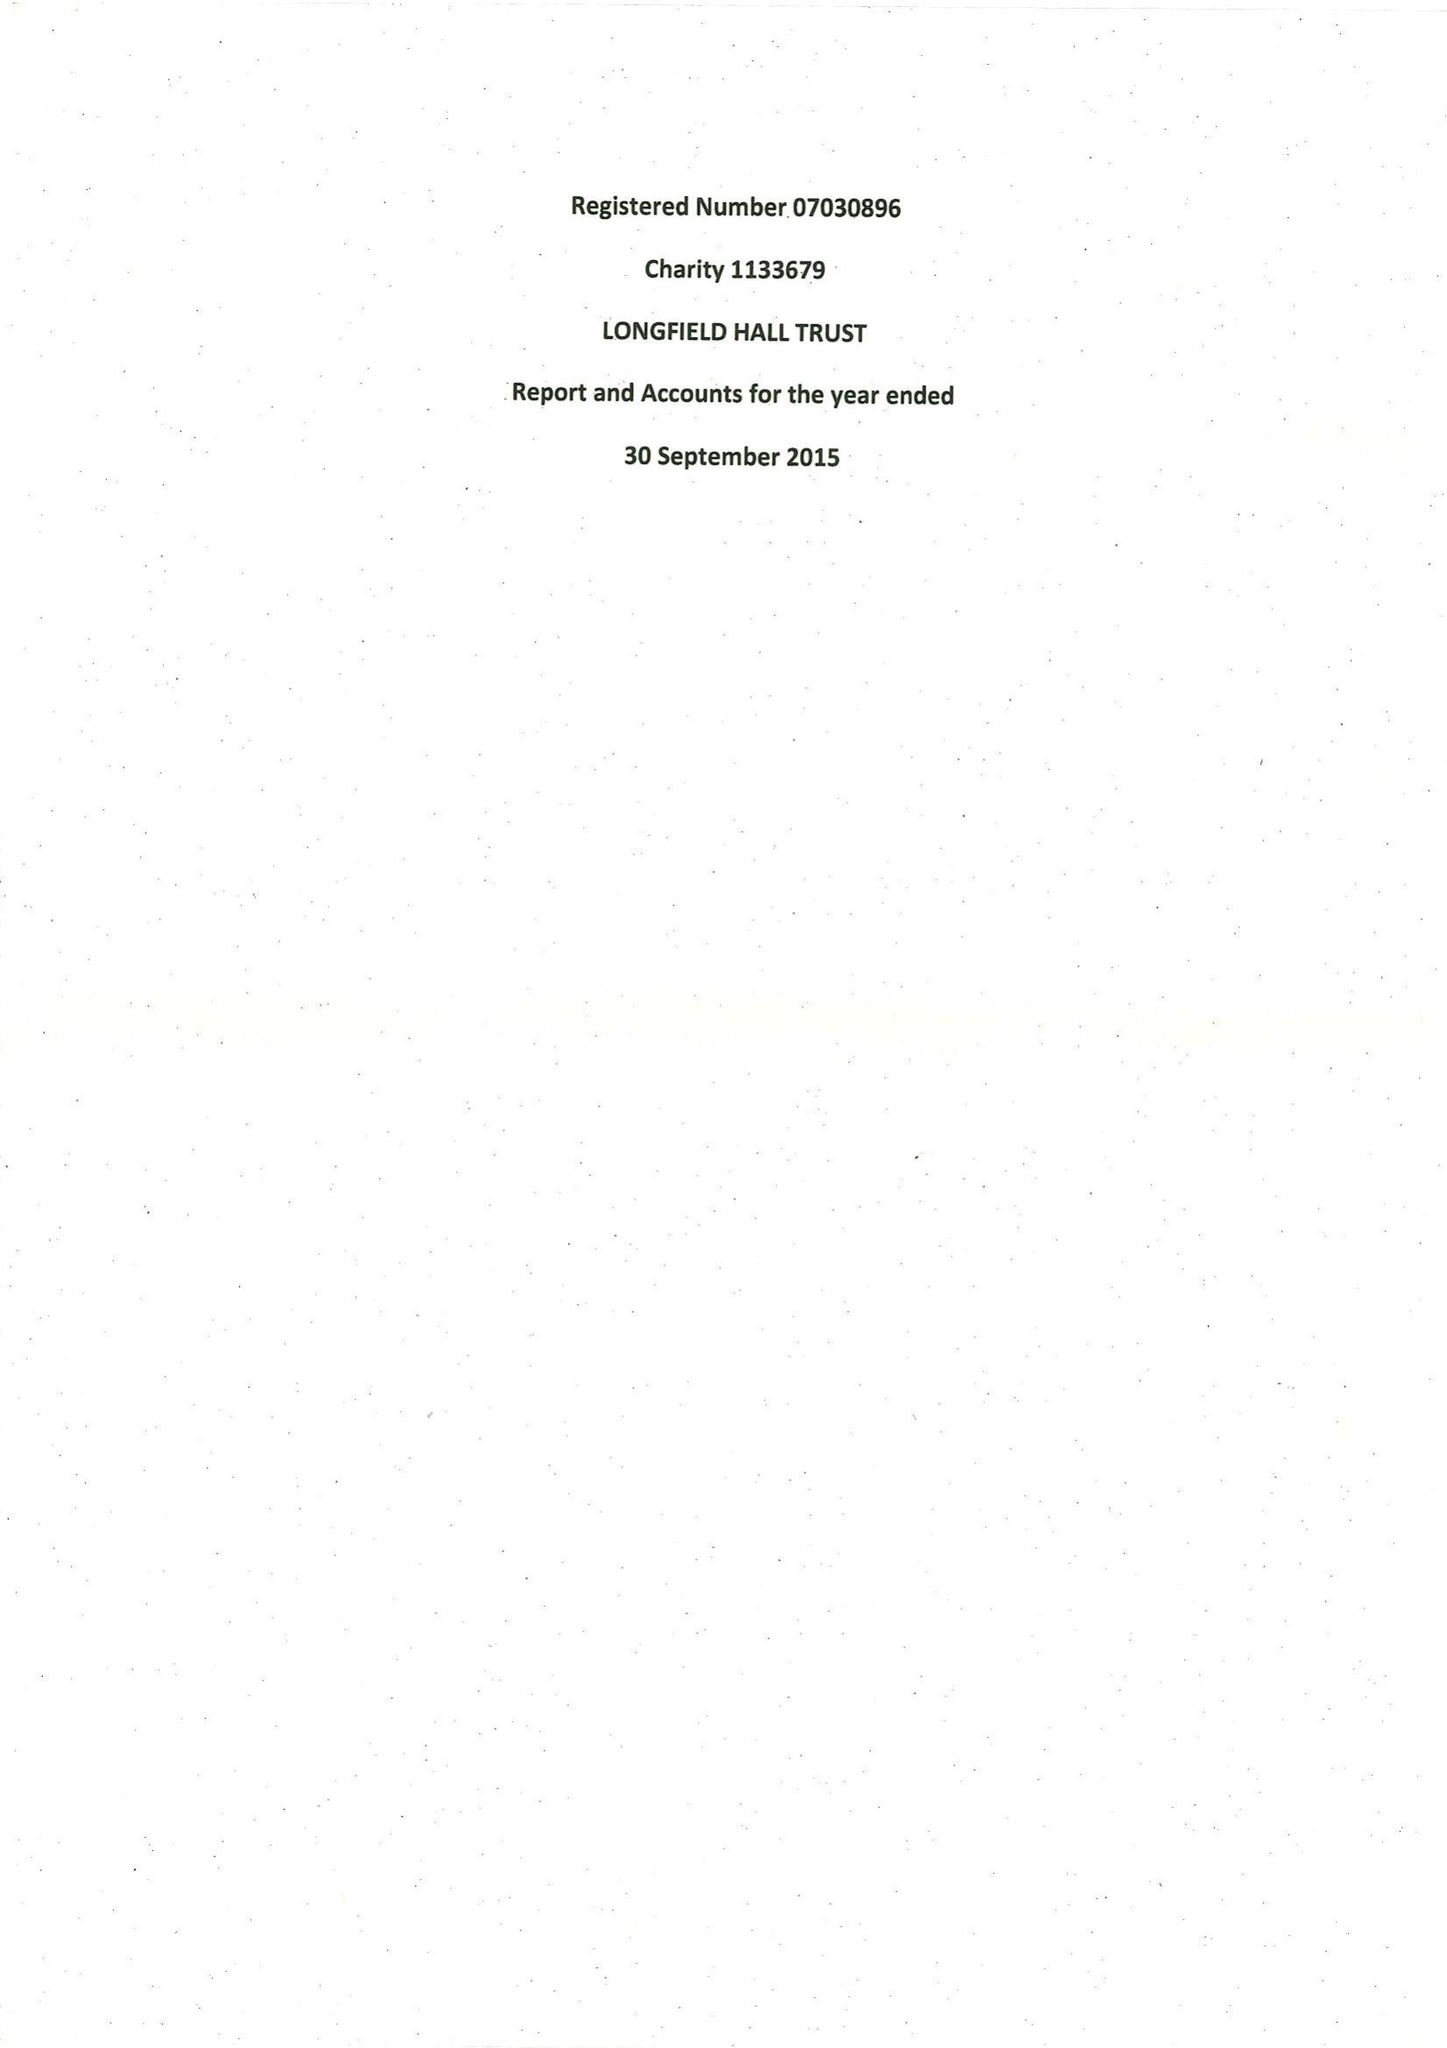What is the value for the report_date?
Answer the question using a single word or phrase. 2015-09-30 